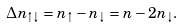Convert formula to latex. <formula><loc_0><loc_0><loc_500><loc_500>\Delta n _ { \uparrow \downarrow } = n _ { \uparrow } - n _ { \downarrow } = n - 2 n _ { \downarrow } .</formula> 